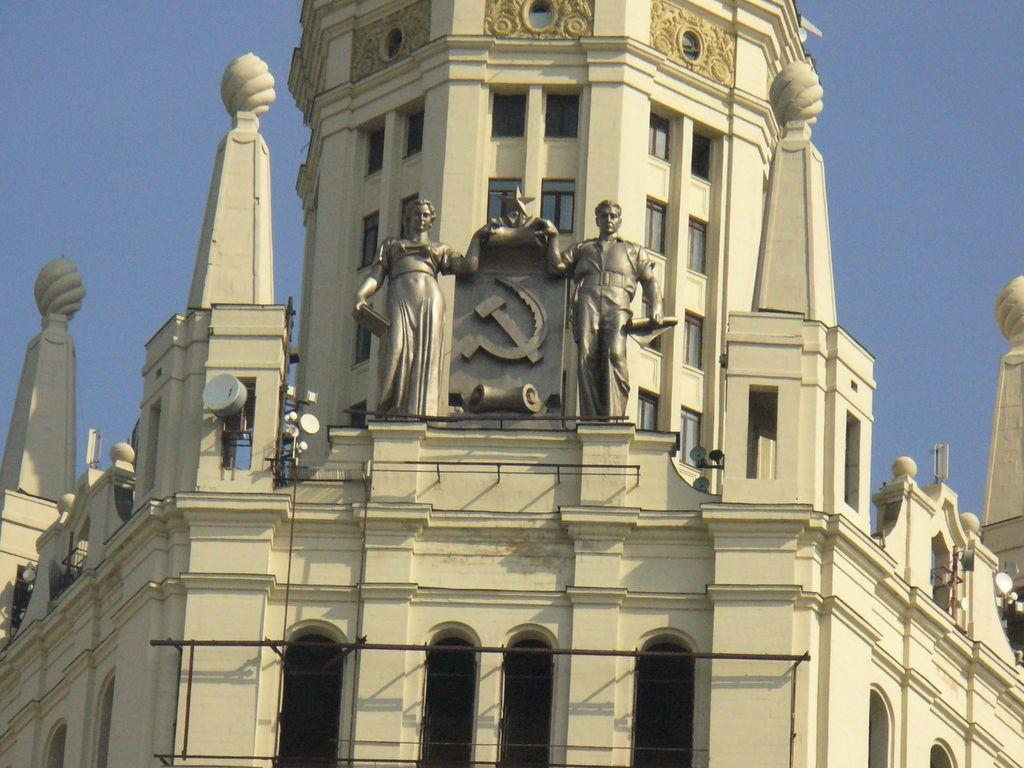Where was the image taken? The image was taken outdoors. What can be seen in the background of the image? There is a sky visible in the background. What is the main subject of the image? The main subject of the image is a building. Can you describe the building in the image? The building has walls, windows, doors, carvings, pillars, and sculptures. What type of agreement is being signed by the farmer in the image? There is no farmer or agreement present in the image; it features a building with various architectural elements. 